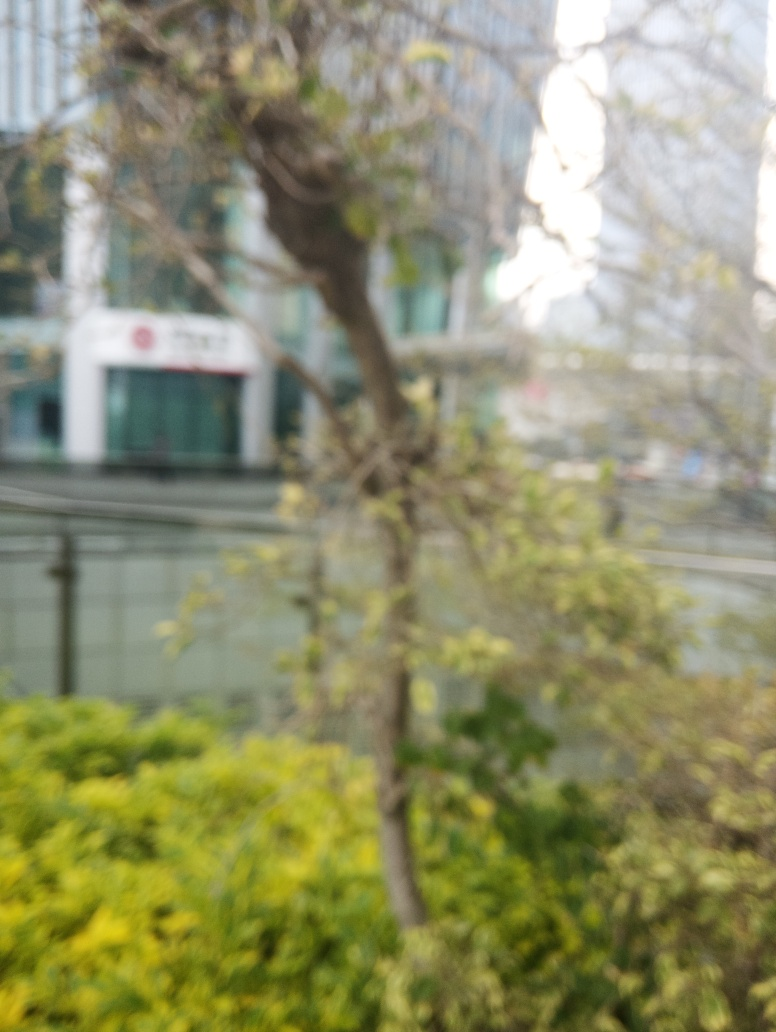Can you clearly see the details of the branches and leaves?
A. Yes
B. No
Answer with the option's letter from the given choices directly.
 B. 